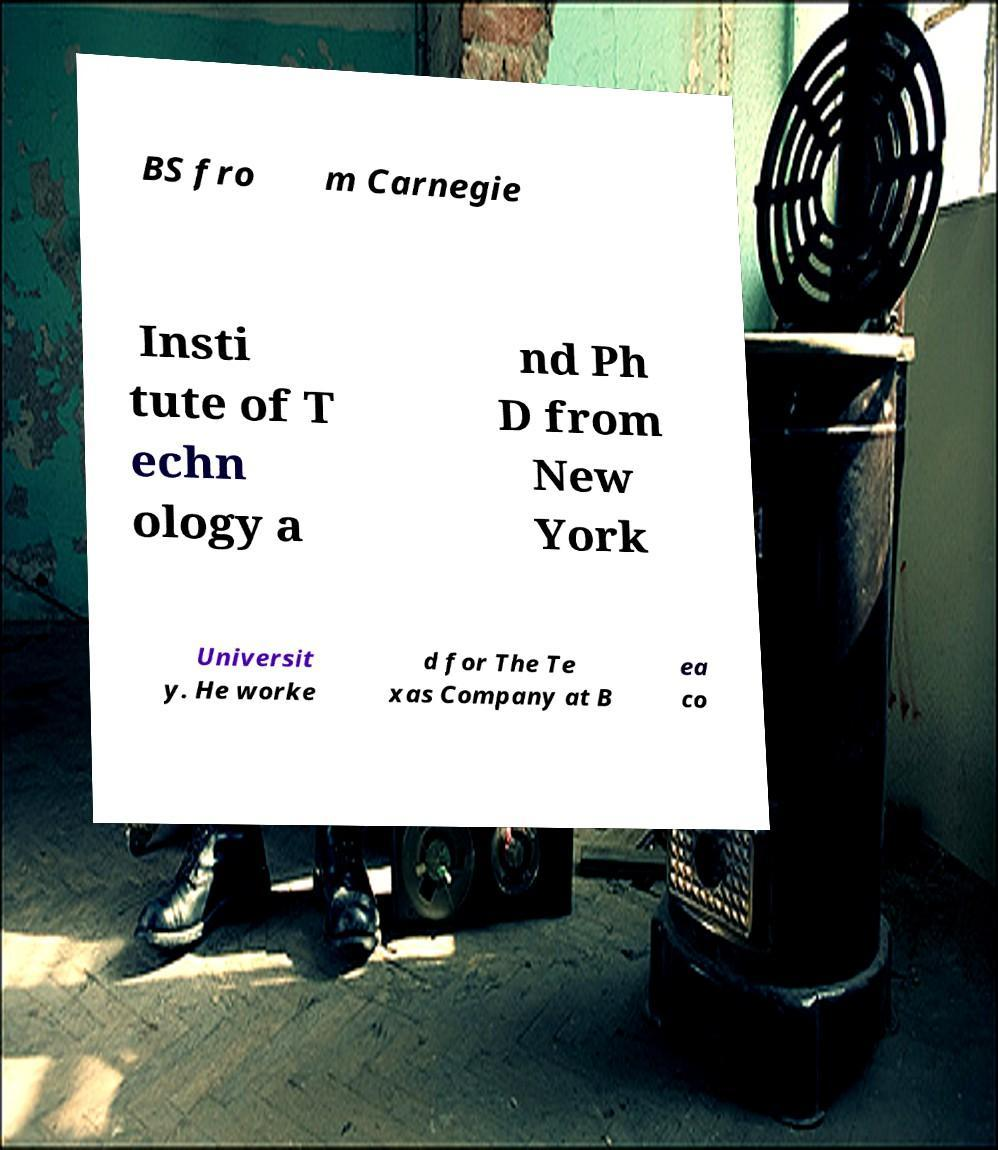Could you extract and type out the text from this image? BS fro m Carnegie Insti tute of T echn ology a nd Ph D from New York Universit y. He worke d for The Te xas Company at B ea co 